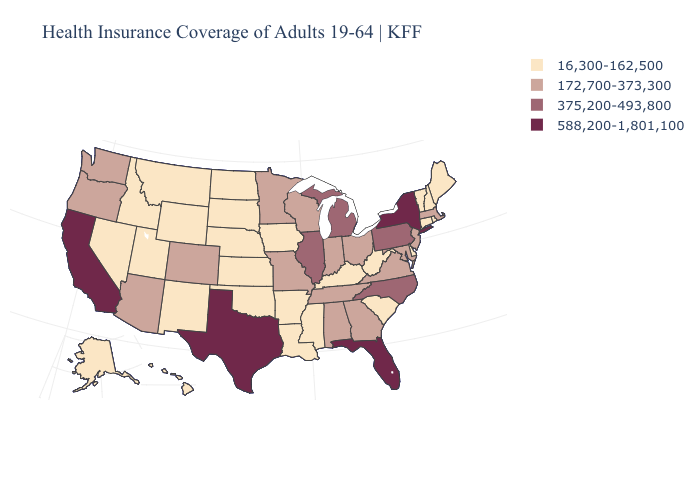Is the legend a continuous bar?
Quick response, please. No. What is the value of Virginia?
Keep it brief. 172,700-373,300. Does Florida have the lowest value in the South?
Give a very brief answer. No. Is the legend a continuous bar?
Be succinct. No. Does the map have missing data?
Quick response, please. No. What is the value of Colorado?
Quick response, please. 172,700-373,300. Name the states that have a value in the range 588,200-1,801,100?
Write a very short answer. California, Florida, New York, Texas. Does Nevada have a higher value than Massachusetts?
Answer briefly. No. How many symbols are there in the legend?
Short answer required. 4. Which states have the highest value in the USA?
Be succinct. California, Florida, New York, Texas. Does the first symbol in the legend represent the smallest category?
Keep it brief. Yes. Name the states that have a value in the range 16,300-162,500?
Be succinct. Alaska, Arkansas, Connecticut, Delaware, Hawaii, Idaho, Iowa, Kansas, Kentucky, Louisiana, Maine, Mississippi, Montana, Nebraska, Nevada, New Hampshire, New Mexico, North Dakota, Oklahoma, Rhode Island, South Carolina, South Dakota, Utah, Vermont, West Virginia, Wyoming. What is the lowest value in the Northeast?
Keep it brief. 16,300-162,500. Which states have the lowest value in the USA?
Write a very short answer. Alaska, Arkansas, Connecticut, Delaware, Hawaii, Idaho, Iowa, Kansas, Kentucky, Louisiana, Maine, Mississippi, Montana, Nebraska, Nevada, New Hampshire, New Mexico, North Dakota, Oklahoma, Rhode Island, South Carolina, South Dakota, Utah, Vermont, West Virginia, Wyoming. What is the highest value in the South ?
Concise answer only. 588,200-1,801,100. 